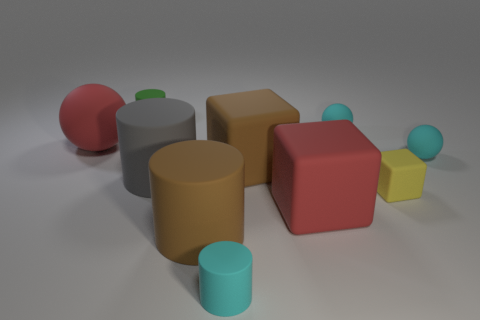Subtract all tiny rubber balls. How many balls are left? 1 Subtract all cyan balls. How many balls are left? 1 Subtract 3 cubes. How many cubes are left? 0 Subtract all yellow balls. How many red blocks are left? 1 Subtract all tiny objects. Subtract all tiny purple matte cylinders. How many objects are left? 5 Add 2 large gray cylinders. How many large gray cylinders are left? 3 Add 3 large matte spheres. How many large matte spheres exist? 4 Subtract 0 blue cylinders. How many objects are left? 10 Subtract all cylinders. How many objects are left? 6 Subtract all brown balls. Subtract all yellow cylinders. How many balls are left? 3 